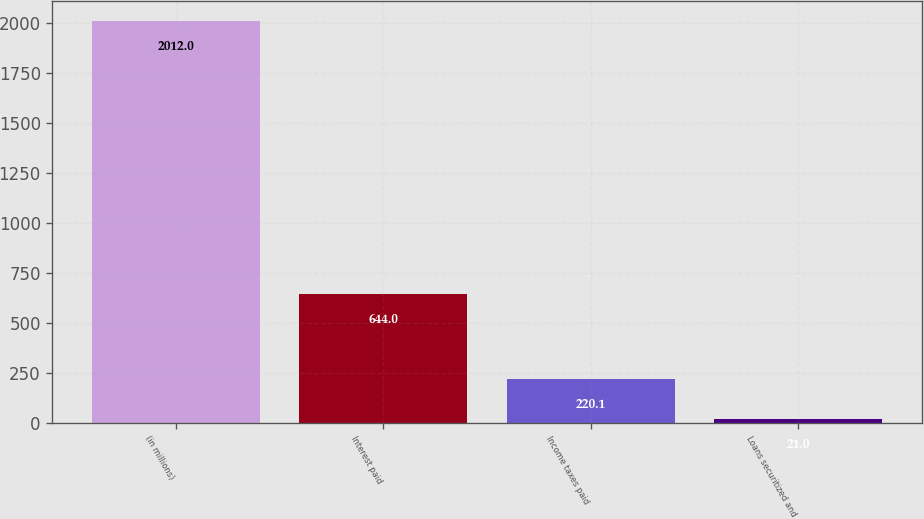Convert chart to OTSL. <chart><loc_0><loc_0><loc_500><loc_500><bar_chart><fcel>(in millions)<fcel>Interest paid<fcel>Income taxes paid<fcel>Loans securitized and<nl><fcel>2012<fcel>644<fcel>220.1<fcel>21<nl></chart> 